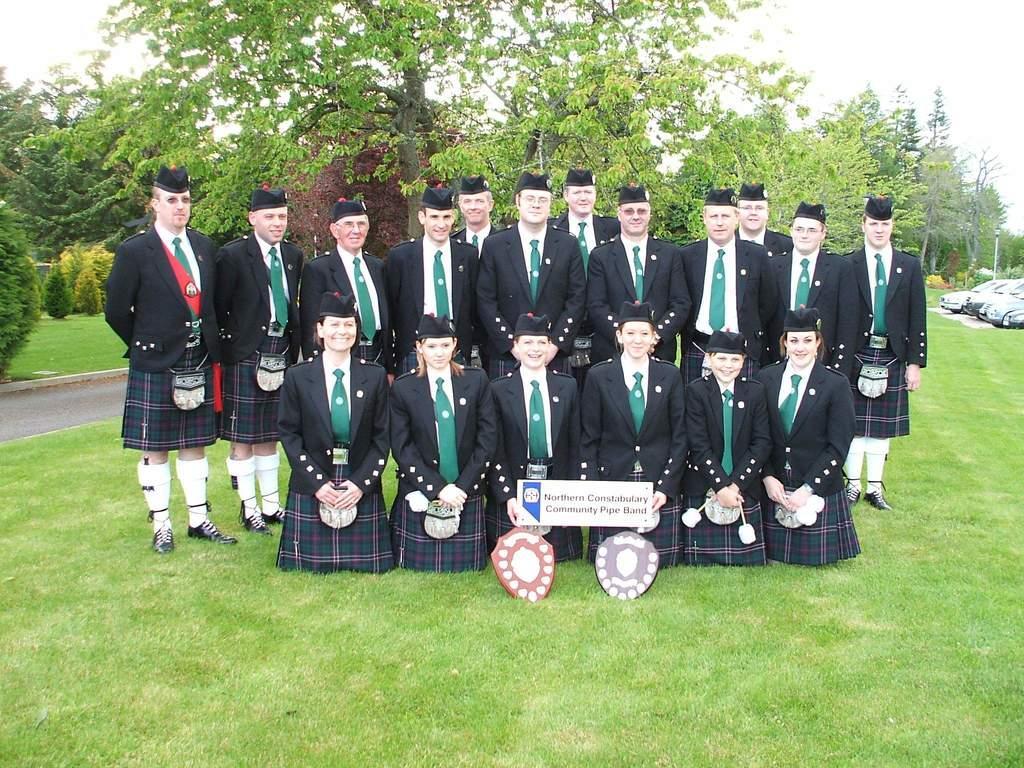How would you summarize this image in a sentence or two? In the picture we can see few men and women, men are standing and women are sitting on the knees in front of them they all are wearing a uniforms like blazers, ties which are green in color and two women are holding some board and two shields on the grass surface and in the background we can see a path with grass surface, plants and trees on it and we can see also see a sky. 